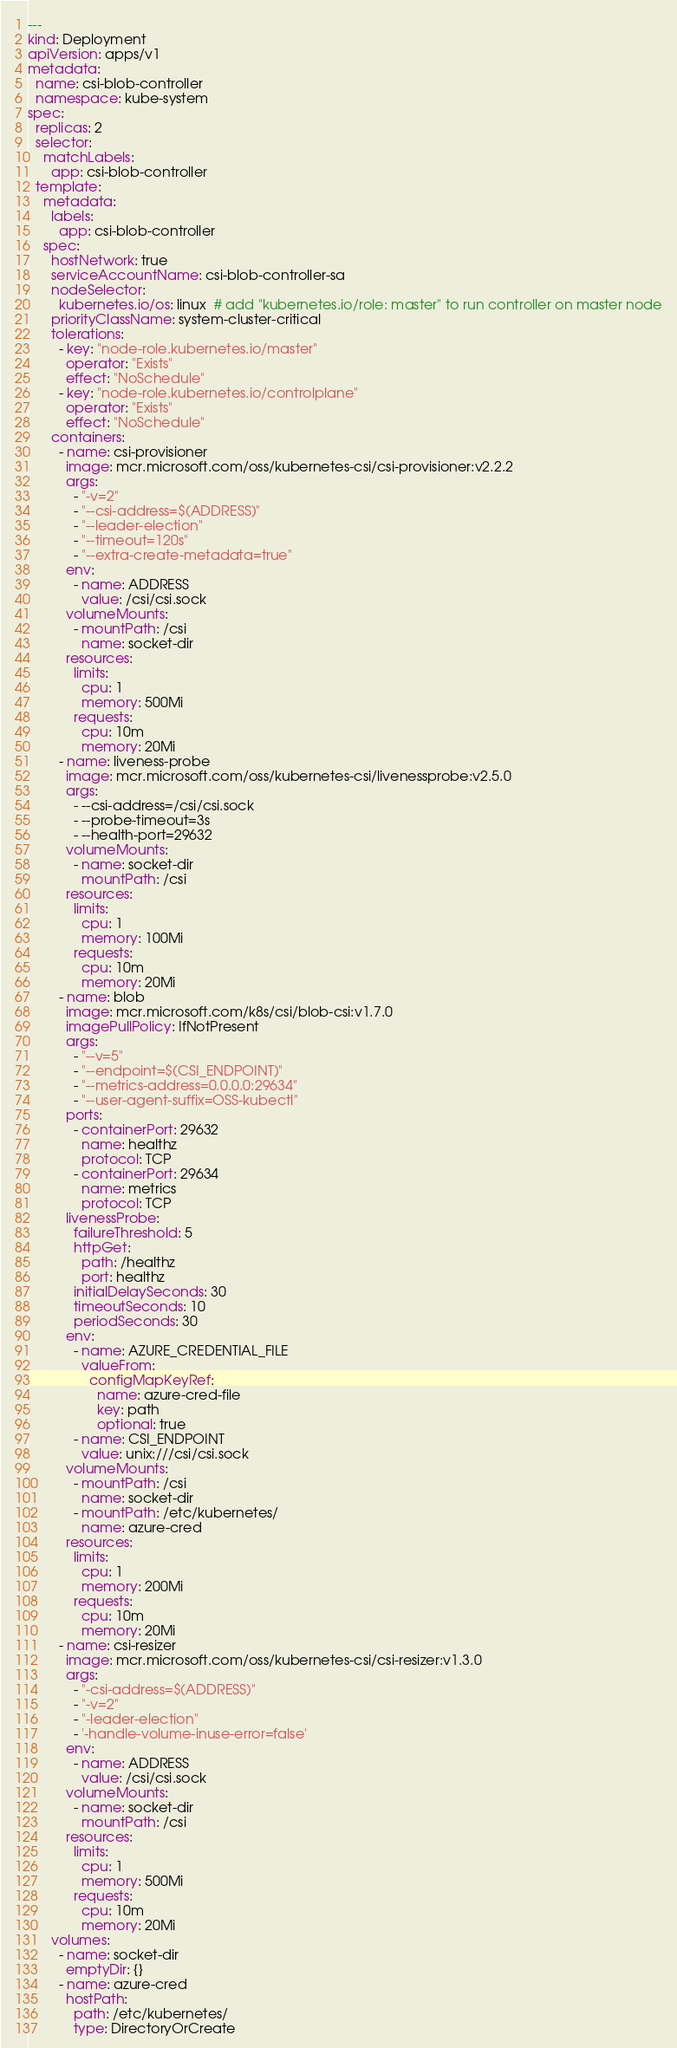Convert code to text. <code><loc_0><loc_0><loc_500><loc_500><_YAML_>---
kind: Deployment
apiVersion: apps/v1
metadata:
  name: csi-blob-controller
  namespace: kube-system
spec:
  replicas: 2
  selector:
    matchLabels:
      app: csi-blob-controller
  template:
    metadata:
      labels:
        app: csi-blob-controller
    spec:
      hostNetwork: true
      serviceAccountName: csi-blob-controller-sa
      nodeSelector:
        kubernetes.io/os: linux  # add "kubernetes.io/role: master" to run controller on master node
      priorityClassName: system-cluster-critical
      tolerations:
        - key: "node-role.kubernetes.io/master"
          operator: "Exists"
          effect: "NoSchedule"
        - key: "node-role.kubernetes.io/controlplane"
          operator: "Exists"
          effect: "NoSchedule"
      containers:
        - name: csi-provisioner
          image: mcr.microsoft.com/oss/kubernetes-csi/csi-provisioner:v2.2.2
          args:
            - "-v=2"
            - "--csi-address=$(ADDRESS)"
            - "--leader-election"
            - "--timeout=120s"
            - "--extra-create-metadata=true"
          env:
            - name: ADDRESS
              value: /csi/csi.sock
          volumeMounts:
            - mountPath: /csi
              name: socket-dir
          resources:
            limits:
              cpu: 1
              memory: 500Mi
            requests:
              cpu: 10m
              memory: 20Mi
        - name: liveness-probe
          image: mcr.microsoft.com/oss/kubernetes-csi/livenessprobe:v2.5.0
          args:
            - --csi-address=/csi/csi.sock
            - --probe-timeout=3s
            - --health-port=29632
          volumeMounts:
            - name: socket-dir
              mountPath: /csi
          resources:
            limits:
              cpu: 1
              memory: 100Mi
            requests:
              cpu: 10m
              memory: 20Mi
        - name: blob
          image: mcr.microsoft.com/k8s/csi/blob-csi:v1.7.0
          imagePullPolicy: IfNotPresent
          args:
            - "--v=5"
            - "--endpoint=$(CSI_ENDPOINT)"
            - "--metrics-address=0.0.0.0:29634"
            - "--user-agent-suffix=OSS-kubectl"
          ports:
            - containerPort: 29632
              name: healthz
              protocol: TCP
            - containerPort: 29634
              name: metrics
              protocol: TCP
          livenessProbe:
            failureThreshold: 5
            httpGet:
              path: /healthz
              port: healthz
            initialDelaySeconds: 30
            timeoutSeconds: 10
            periodSeconds: 30
          env:
            - name: AZURE_CREDENTIAL_FILE
              valueFrom:
                configMapKeyRef:
                  name: azure-cred-file
                  key: path
                  optional: true
            - name: CSI_ENDPOINT
              value: unix:///csi/csi.sock
          volumeMounts:
            - mountPath: /csi
              name: socket-dir
            - mountPath: /etc/kubernetes/
              name: azure-cred
          resources:
            limits:
              cpu: 1
              memory: 200Mi
            requests:
              cpu: 10m
              memory: 20Mi
        - name: csi-resizer
          image: mcr.microsoft.com/oss/kubernetes-csi/csi-resizer:v1.3.0
          args:
            - "-csi-address=$(ADDRESS)"
            - "-v=2"
            - "-leader-election"
            - '-handle-volume-inuse-error=false'
          env:
            - name: ADDRESS
              value: /csi/csi.sock
          volumeMounts:
            - name: socket-dir
              mountPath: /csi
          resources:
            limits:
              cpu: 1
              memory: 500Mi
            requests:
              cpu: 10m
              memory: 20Mi
      volumes:
        - name: socket-dir
          emptyDir: {}
        - name: azure-cred
          hostPath:
            path: /etc/kubernetes/
            type: DirectoryOrCreate
</code> 